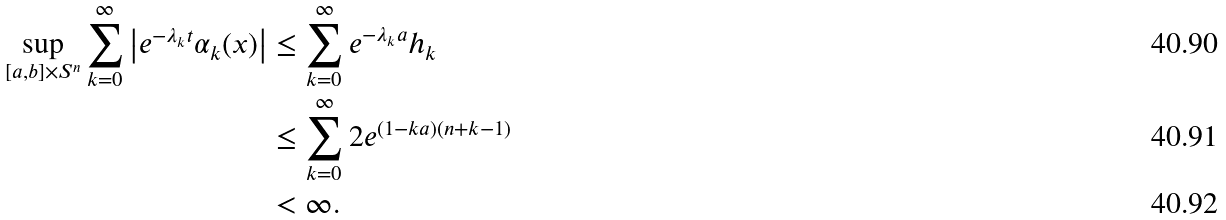Convert formula to latex. <formula><loc_0><loc_0><loc_500><loc_500>\sup _ { [ a , b ] \times S ^ { n } } \sum _ { k = 0 } ^ { \infty } \begin{vmatrix} e ^ { - \lambda _ { k } t } \alpha _ { k } ( x ) \end{vmatrix} & \leq \sum _ { k = 0 } ^ { \infty } e ^ { - \lambda _ { k } a } h _ { k } \\ & \leq \sum _ { k = 0 } ^ { \infty } 2 e ^ { ( 1 - k a ) ( n + k - 1 ) } \\ & < \infty .</formula> 